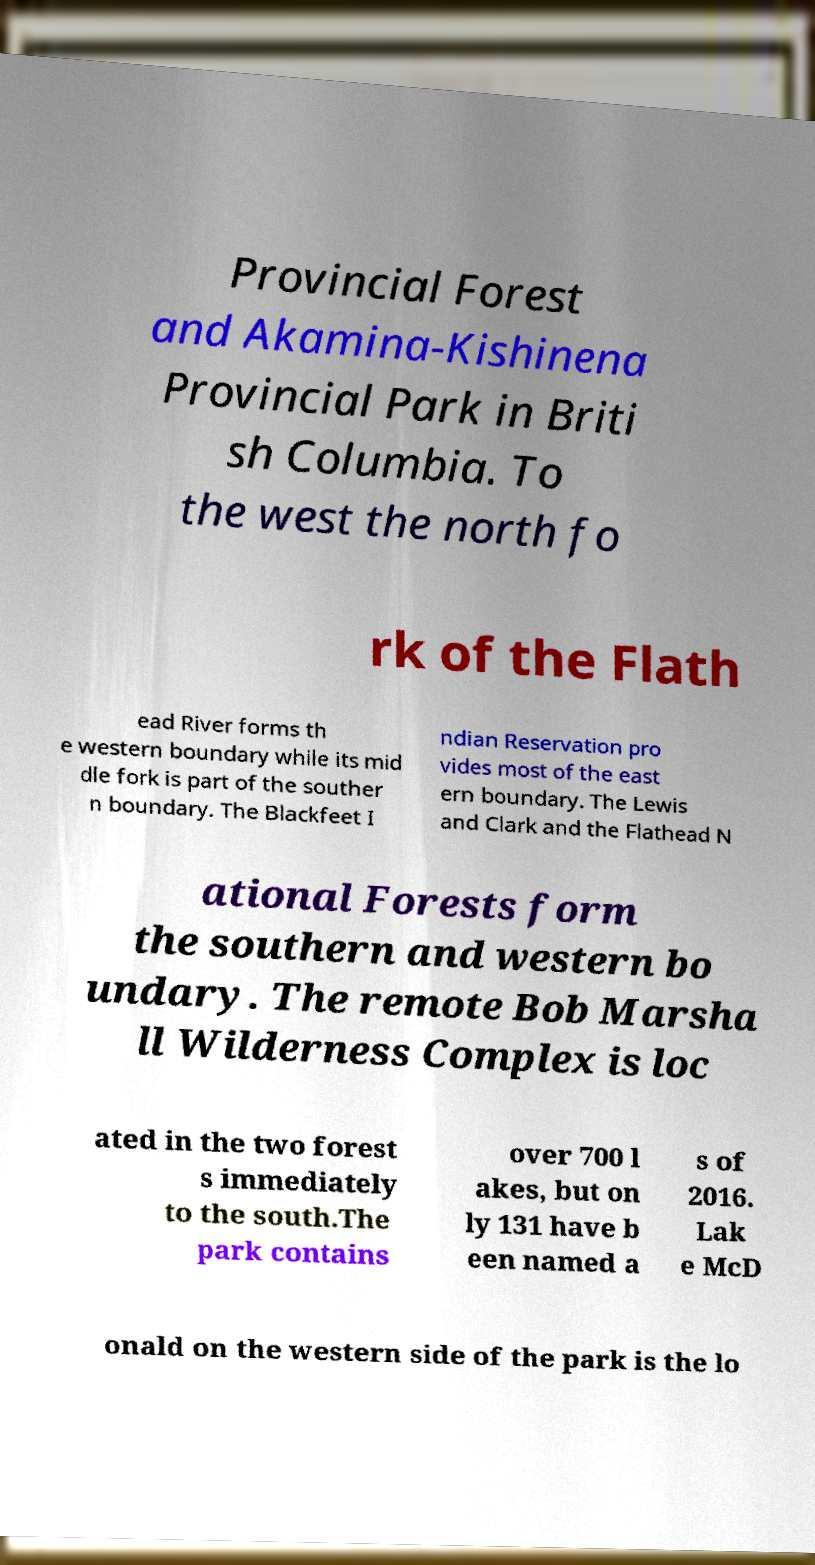Could you assist in decoding the text presented in this image and type it out clearly? Provincial Forest and Akamina-Kishinena Provincial Park in Briti sh Columbia. To the west the north fo rk of the Flath ead River forms th e western boundary while its mid dle fork is part of the souther n boundary. The Blackfeet I ndian Reservation pro vides most of the east ern boundary. The Lewis and Clark and the Flathead N ational Forests form the southern and western bo undary. The remote Bob Marsha ll Wilderness Complex is loc ated in the two forest s immediately to the south.The park contains over 700 l akes, but on ly 131 have b een named a s of 2016. Lak e McD onald on the western side of the park is the lo 